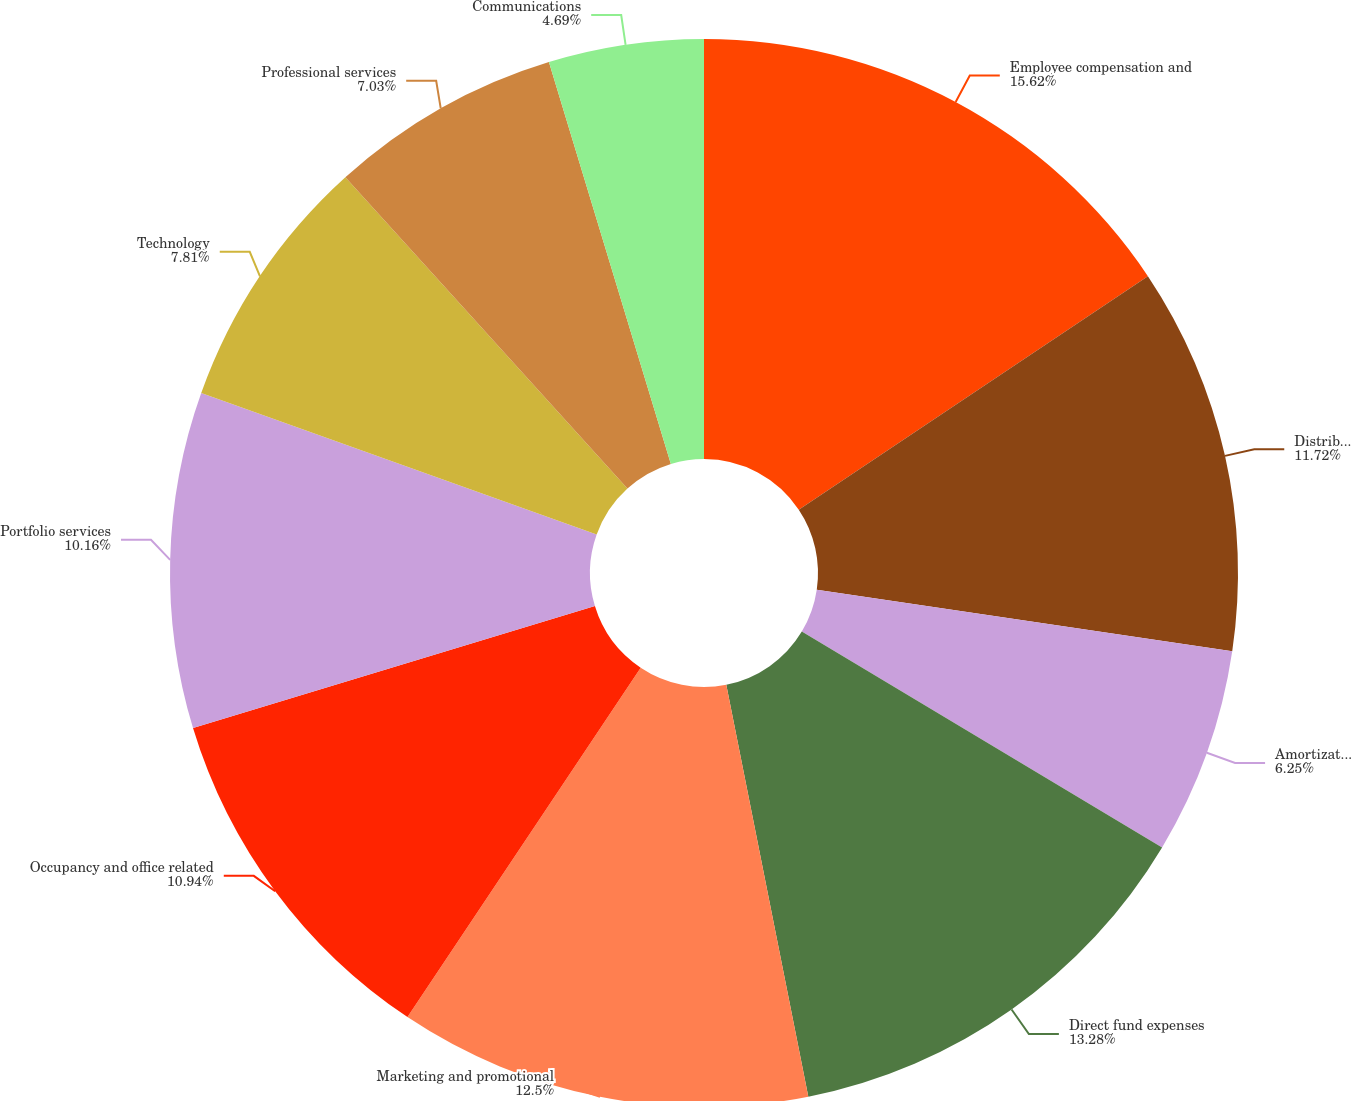<chart> <loc_0><loc_0><loc_500><loc_500><pie_chart><fcel>Employee compensation and<fcel>Distribution and servicing<fcel>Amortization of deferred sales<fcel>Direct fund expenses<fcel>Marketing and promotional<fcel>Occupancy and office related<fcel>Portfolio services<fcel>Technology<fcel>Professional services<fcel>Communications<nl><fcel>15.62%<fcel>11.72%<fcel>6.25%<fcel>13.28%<fcel>12.5%<fcel>10.94%<fcel>10.16%<fcel>7.81%<fcel>7.03%<fcel>4.69%<nl></chart> 